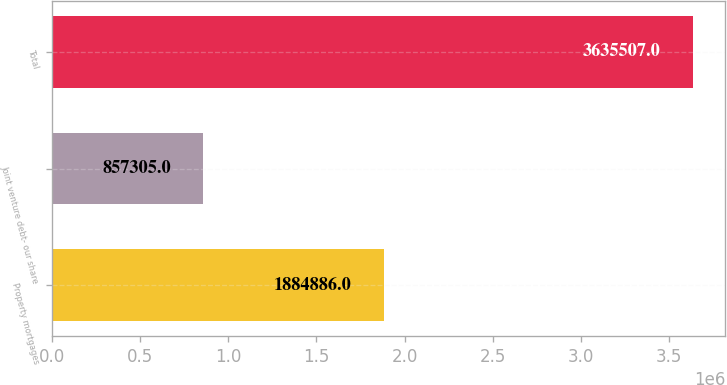<chart> <loc_0><loc_0><loc_500><loc_500><bar_chart><fcel>Property mortgages<fcel>Joint venture debt- our share<fcel>Total<nl><fcel>1.88489e+06<fcel>857305<fcel>3.63551e+06<nl></chart> 